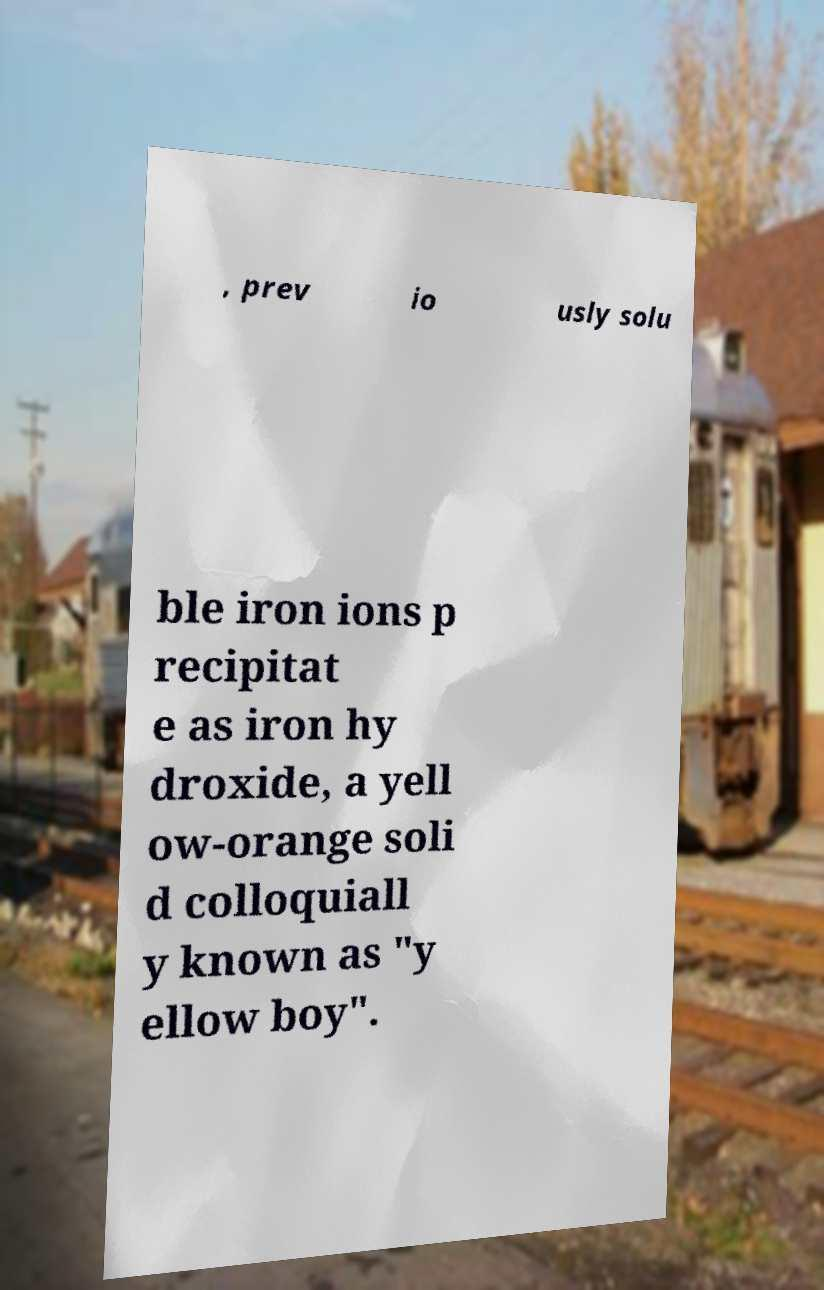What messages or text are displayed in this image? I need them in a readable, typed format. , prev io usly solu ble iron ions p recipitat e as iron hy droxide, a yell ow-orange soli d colloquiall y known as "y ellow boy". 